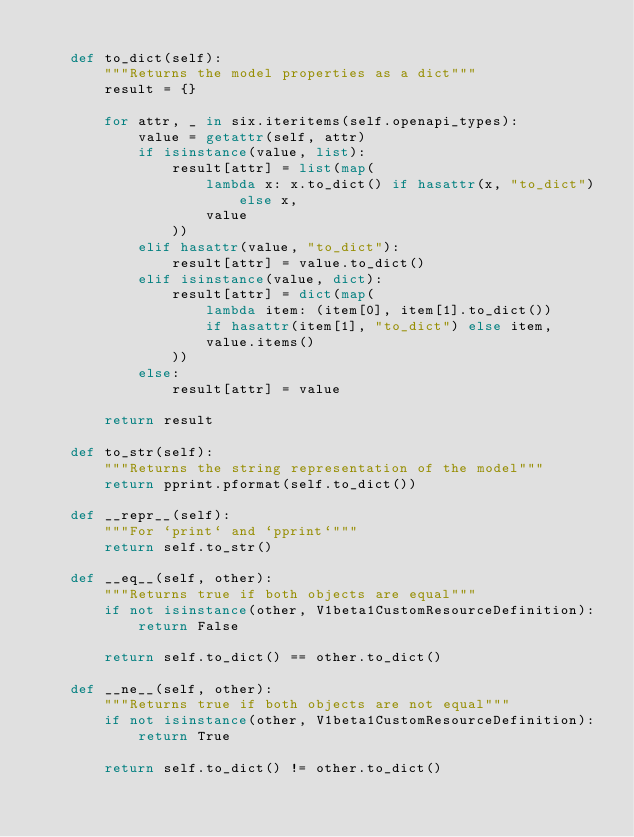Convert code to text. <code><loc_0><loc_0><loc_500><loc_500><_Python_>
    def to_dict(self):
        """Returns the model properties as a dict"""
        result = {}

        for attr, _ in six.iteritems(self.openapi_types):
            value = getattr(self, attr)
            if isinstance(value, list):
                result[attr] = list(map(
                    lambda x: x.to_dict() if hasattr(x, "to_dict") else x,
                    value
                ))
            elif hasattr(value, "to_dict"):
                result[attr] = value.to_dict()
            elif isinstance(value, dict):
                result[attr] = dict(map(
                    lambda item: (item[0], item[1].to_dict())
                    if hasattr(item[1], "to_dict") else item,
                    value.items()
                ))
            else:
                result[attr] = value

        return result

    def to_str(self):
        """Returns the string representation of the model"""
        return pprint.pformat(self.to_dict())

    def __repr__(self):
        """For `print` and `pprint`"""
        return self.to_str()

    def __eq__(self, other):
        """Returns true if both objects are equal"""
        if not isinstance(other, V1beta1CustomResourceDefinition):
            return False

        return self.to_dict() == other.to_dict()

    def __ne__(self, other):
        """Returns true if both objects are not equal"""
        if not isinstance(other, V1beta1CustomResourceDefinition):
            return True

        return self.to_dict() != other.to_dict()
</code> 